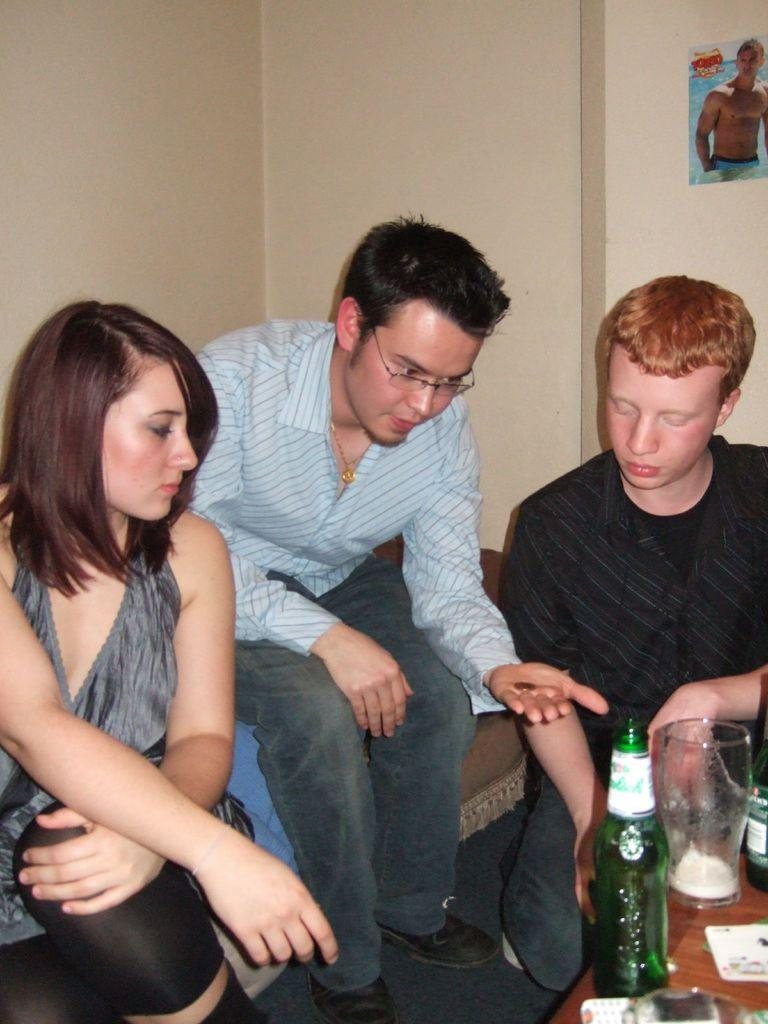How many people are in the image? There are three people in the image: one woman and two men. What are the people in the image doing? The woman and men are sitting. What is in front of them? There is a table in front of them. What can be seen on the table? There are two bottles, a glass, and a mobile on the table. What is visible in the background of the image? There is a wall in the background of the image, and a poster is on the wall. How many pockets can be seen on the woman's dress in the image? There is no information about the woman's dress or pockets in the image. What type of breath is the woman taking in the image? There is no information about the woman's breath in the image. 